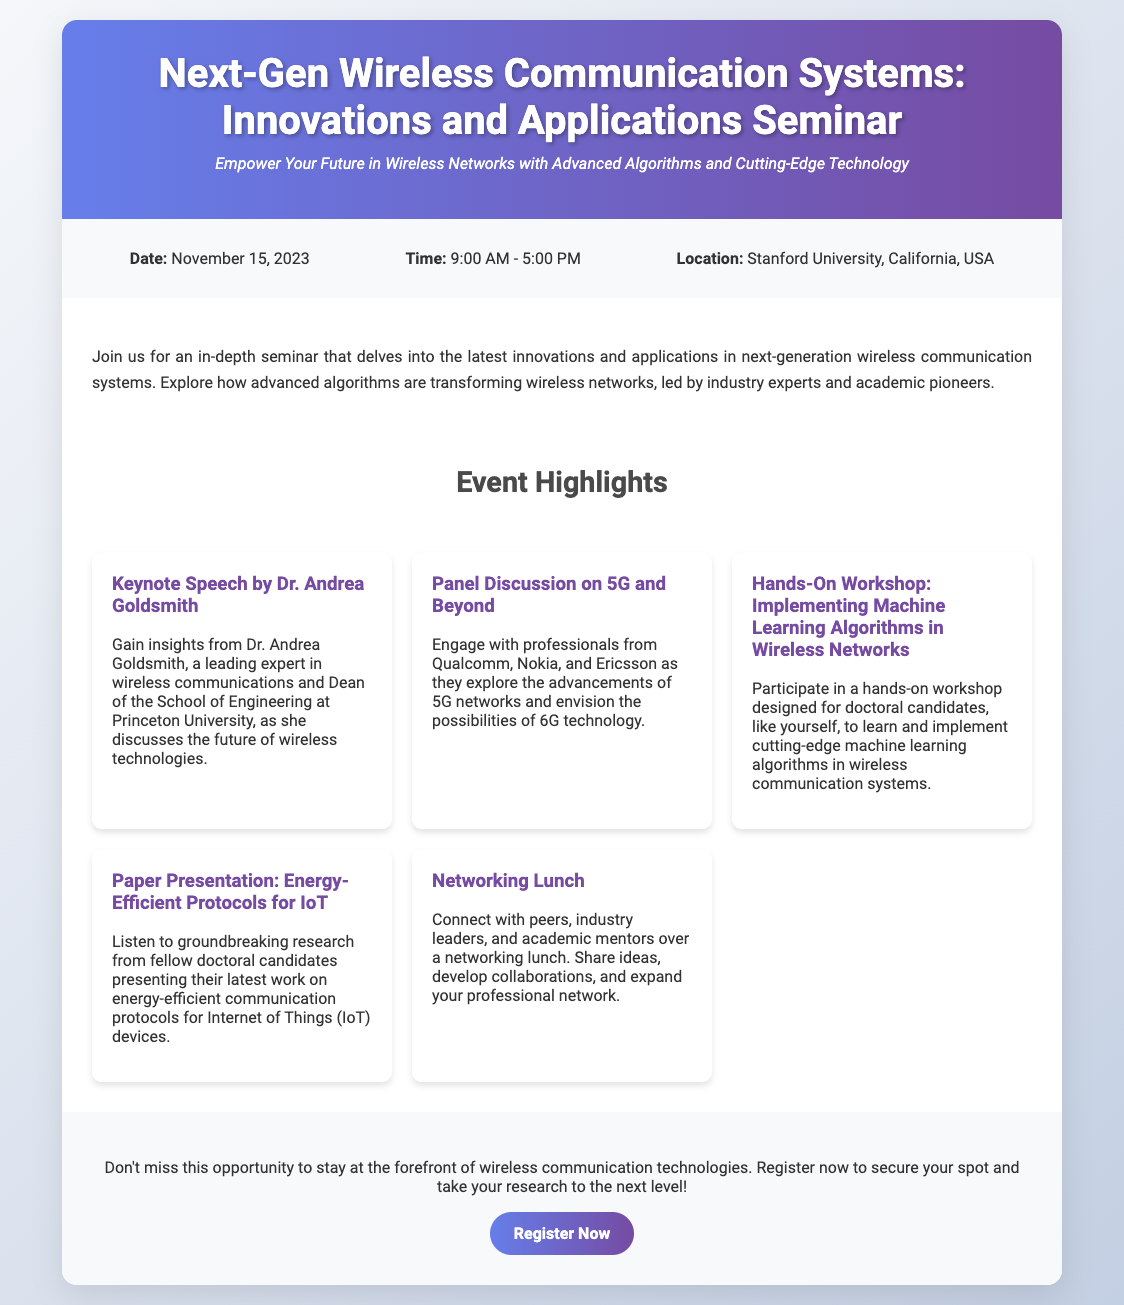What is the date of the seminar? The date of the seminar is explicitly mentioned in the event details section of the document.
Answer: November 15, 2023 What time does the seminar start? The starting time of the seminar is listed clearly in the event details section.
Answer: 9:00 AM Where is the seminar located? The location of the seminar is described in the event details section.
Answer: Stanford University, California, USA Who is giving the keynote speech? The keynote speaker is named in the event highlights section.
Answer: Dr. Andrea Goldsmith What is a topic covered in the panel discussion? The topic of the panel discussion is mentioned in the event highlights section.
Answer: 5G and Beyond Which workshop is specifically designed for doctoral candidates? The workshop designed for doctoral candidates is detailed in the event highlights section.
Answer: Hands-On Workshop: Implementing Machine Learning Algorithms in Wireless Networks What type of session is included for networking? The networking session type is specified in the event highlights section.
Answer: Networking Lunch What is the main focus of the seminar? The main focus of the seminar is summarized in the description section.
Answer: Innovations and applications in next-generation wireless communication systems 